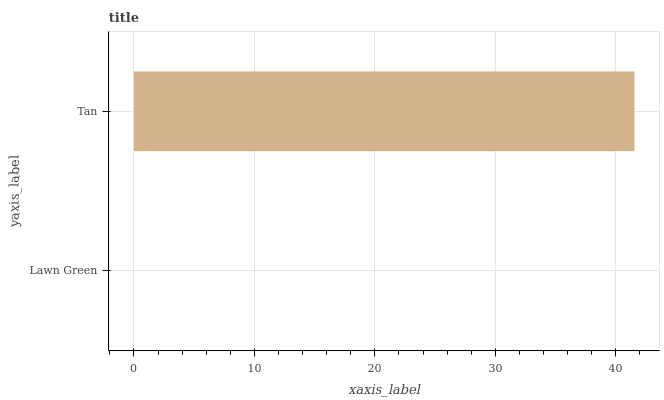Is Lawn Green the minimum?
Answer yes or no. Yes. Is Tan the maximum?
Answer yes or no. Yes. Is Tan the minimum?
Answer yes or no. No. Is Tan greater than Lawn Green?
Answer yes or no. Yes. Is Lawn Green less than Tan?
Answer yes or no. Yes. Is Lawn Green greater than Tan?
Answer yes or no. No. Is Tan less than Lawn Green?
Answer yes or no. No. Is Tan the high median?
Answer yes or no. Yes. Is Lawn Green the low median?
Answer yes or no. Yes. Is Lawn Green the high median?
Answer yes or no. No. Is Tan the low median?
Answer yes or no. No. 